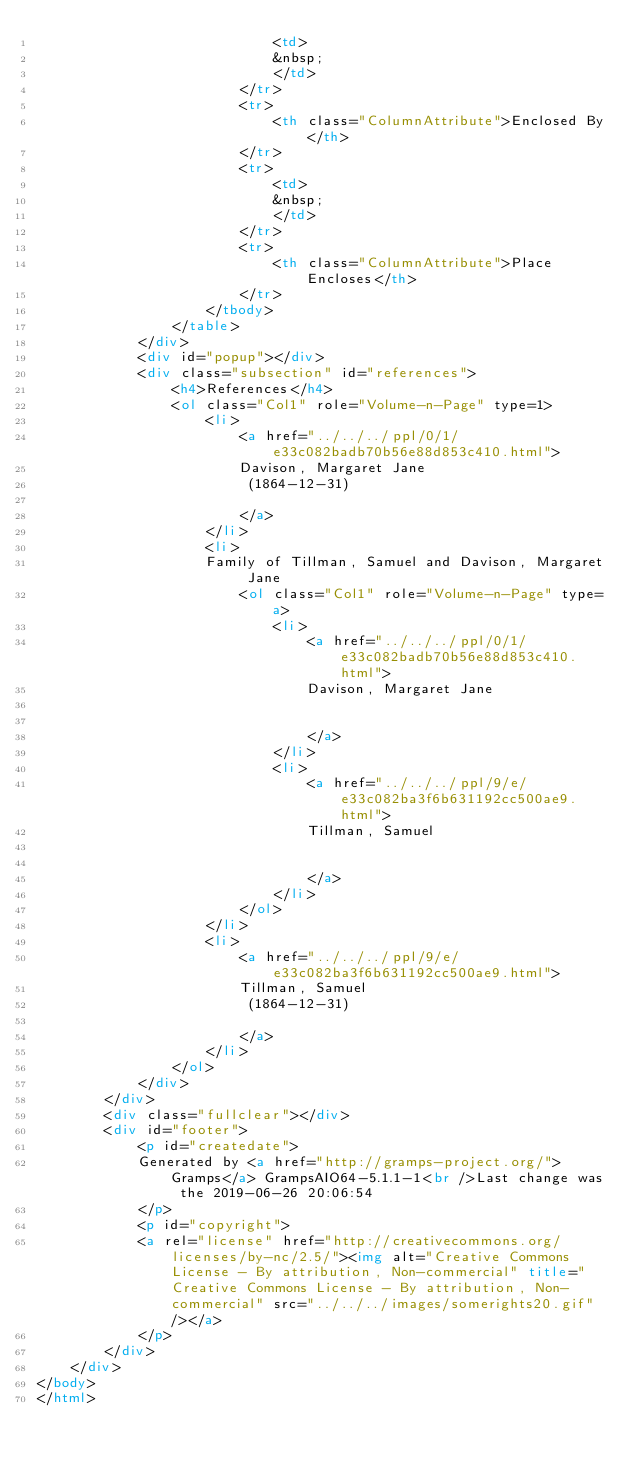<code> <loc_0><loc_0><loc_500><loc_500><_HTML_>							<td>
							&nbsp;
							</td>
						</tr>
						<tr>
							<th class="ColumnAttribute">Enclosed By</th>
						</tr>
						<tr>
							<td>
							&nbsp;
							</td>
						</tr>
						<tr>
							<th class="ColumnAttribute">Place Encloses</th>
						</tr>
					</tbody>
				</table>
			</div>
			<div id="popup"></div>
			<div class="subsection" id="references">
				<h4>References</h4>
				<ol class="Col1" role="Volume-n-Page" type=1>
					<li>
						<a href="../../../ppl/0/1/e33c082badb70b56e88d853c410.html">
						Davison, Margaret Jane
						 (1864-12-31) 
						
						</a>
					</li>
					<li>
					Family of Tillman, Samuel and Davison, Margaret Jane
						<ol class="Col1" role="Volume-n-Page" type=a>
							<li>
								<a href="../../../ppl/0/1/e33c082badb70b56e88d853c410.html">
								Davison, Margaret Jane
								
								
								</a>
							</li>
							<li>
								<a href="../../../ppl/9/e/e33c082ba3f6b631192cc500ae9.html">
								Tillman, Samuel
								
								
								</a>
							</li>
						</ol>
					</li>
					<li>
						<a href="../../../ppl/9/e/e33c082ba3f6b631192cc500ae9.html">
						Tillman, Samuel
						 (1864-12-31) 
						
						</a>
					</li>
				</ol>
			</div>
		</div>
		<div class="fullclear"></div>
		<div id="footer">
			<p id="createdate">
			Generated by <a href="http://gramps-project.org/">Gramps</a> GrampsAIO64-5.1.1-1<br />Last change was the 2019-06-26 20:06:54
			</p>
			<p id="copyright">
			<a rel="license" href="http://creativecommons.org/licenses/by-nc/2.5/"><img alt="Creative Commons License - By attribution, Non-commercial" title="Creative Commons License - By attribution, Non-commercial" src="../../../images/somerights20.gif" /></a>
			</p>
		</div>
	</div>
</body>
</html>
</code> 